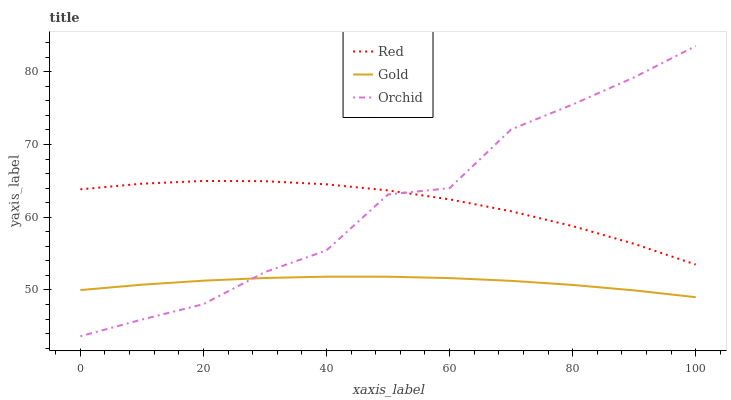Does Gold have the minimum area under the curve?
Answer yes or no. Yes. Does Red have the maximum area under the curve?
Answer yes or no. Yes. Does Orchid have the minimum area under the curve?
Answer yes or no. No. Does Orchid have the maximum area under the curve?
Answer yes or no. No. Is Gold the smoothest?
Answer yes or no. Yes. Is Orchid the roughest?
Answer yes or no. Yes. Is Red the smoothest?
Answer yes or no. No. Is Red the roughest?
Answer yes or no. No. Does Orchid have the lowest value?
Answer yes or no. Yes. Does Red have the lowest value?
Answer yes or no. No. Does Orchid have the highest value?
Answer yes or no. Yes. Does Red have the highest value?
Answer yes or no. No. Is Gold less than Red?
Answer yes or no. Yes. Is Red greater than Gold?
Answer yes or no. Yes. Does Red intersect Orchid?
Answer yes or no. Yes. Is Red less than Orchid?
Answer yes or no. No. Is Red greater than Orchid?
Answer yes or no. No. Does Gold intersect Red?
Answer yes or no. No. 